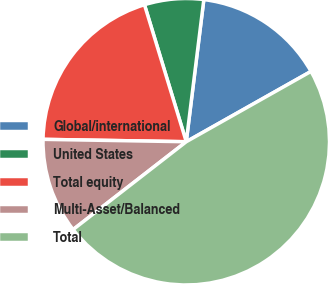Convert chart to OTSL. <chart><loc_0><loc_0><loc_500><loc_500><pie_chart><fcel>Global/international<fcel>United States<fcel>Total equity<fcel>Multi-Asset/Balanced<fcel>Total<nl><fcel>14.87%<fcel>6.67%<fcel>20.02%<fcel>10.77%<fcel>47.66%<nl></chart> 